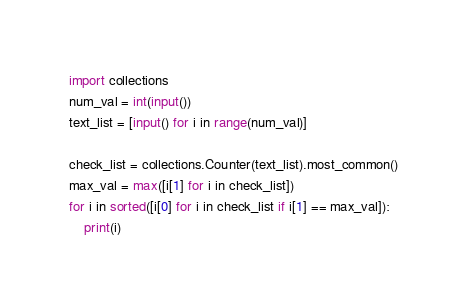<code> <loc_0><loc_0><loc_500><loc_500><_Python_>import collections
num_val = int(input())
text_list = [input() for i in range(num_val)]

check_list = collections.Counter(text_list).most_common()
max_val = max([i[1] for i in check_list])
for i in sorted([i[0] for i in check_list if i[1] == max_val]):
    print(i)</code> 